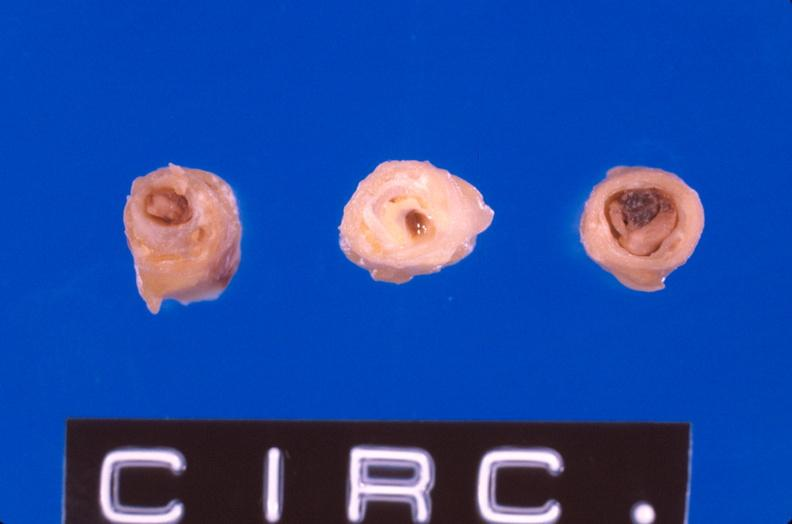what does this image show?
Answer the question using a single word or phrase. Coronary artery atherosclerosis 